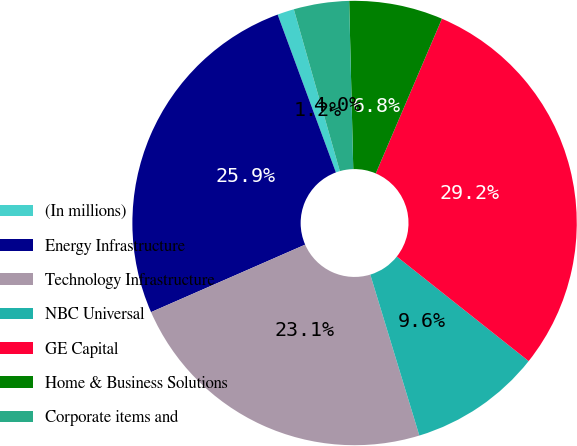<chart> <loc_0><loc_0><loc_500><loc_500><pie_chart><fcel>(In millions)<fcel>Energy Infrastructure<fcel>Technology Infrastructure<fcel>NBC Universal<fcel>GE Capital<fcel>Home & Business Solutions<fcel>Corporate items and<nl><fcel>1.22%<fcel>25.94%<fcel>23.14%<fcel>9.62%<fcel>29.24%<fcel>6.82%<fcel>4.02%<nl></chart> 